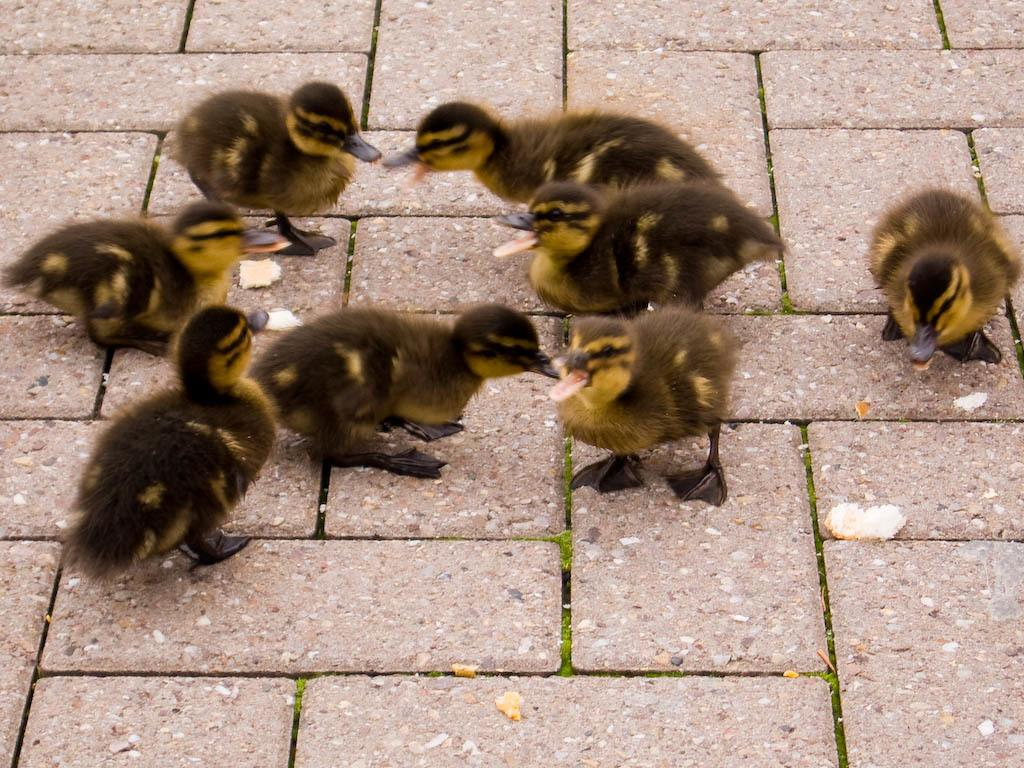What animals can be seen on the surface in the image? There are ducks on the surface in the image. What else is visible in the image besides the ducks? There are pieces of food visible in the image. Can you tell me how many parents are present in the image? There are no parents present in the image; it features ducks and pieces of food. What type of thumb can be seen interacting with the ducks in the image? There is no thumb present in the image; it only features ducks and pieces of food. 